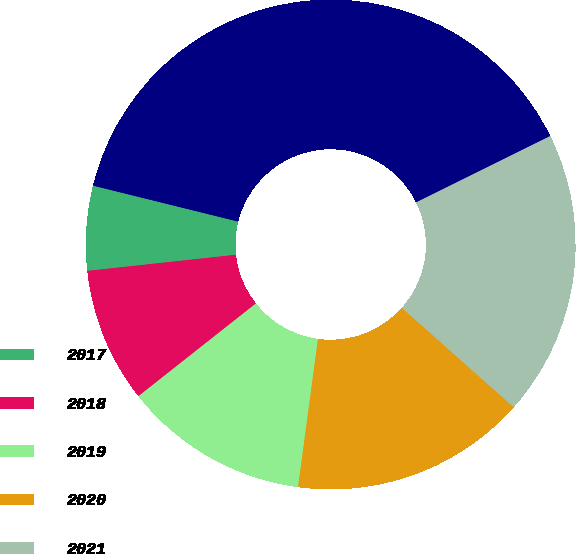<chart> <loc_0><loc_0><loc_500><loc_500><pie_chart><fcel>2017<fcel>2018<fcel>2019<fcel>2020<fcel>2021<fcel>2022 through 2026<nl><fcel>5.59%<fcel>8.91%<fcel>12.24%<fcel>15.56%<fcel>18.88%<fcel>38.82%<nl></chart> 